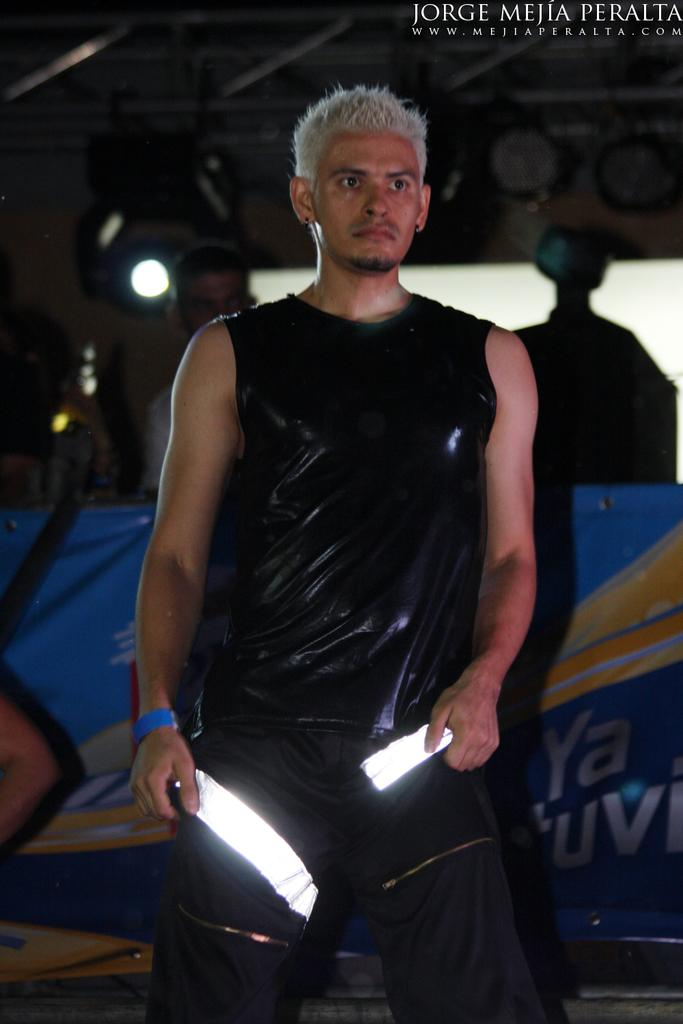<image>
Give a short and clear explanation of the subsequent image. A man with reflective stripes on his pants is photographed by Jorge Mejia Peralta. 